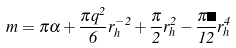Convert formula to latex. <formula><loc_0><loc_0><loc_500><loc_500>m = \pi \alpha + \frac { \pi q ^ { 2 } } { 6 } r _ { h } ^ { - 2 } + \frac { \pi } { 2 } r _ { h } ^ { 2 } - \frac { \pi \Lambda } { 1 2 } r _ { h } ^ { 4 }</formula> 